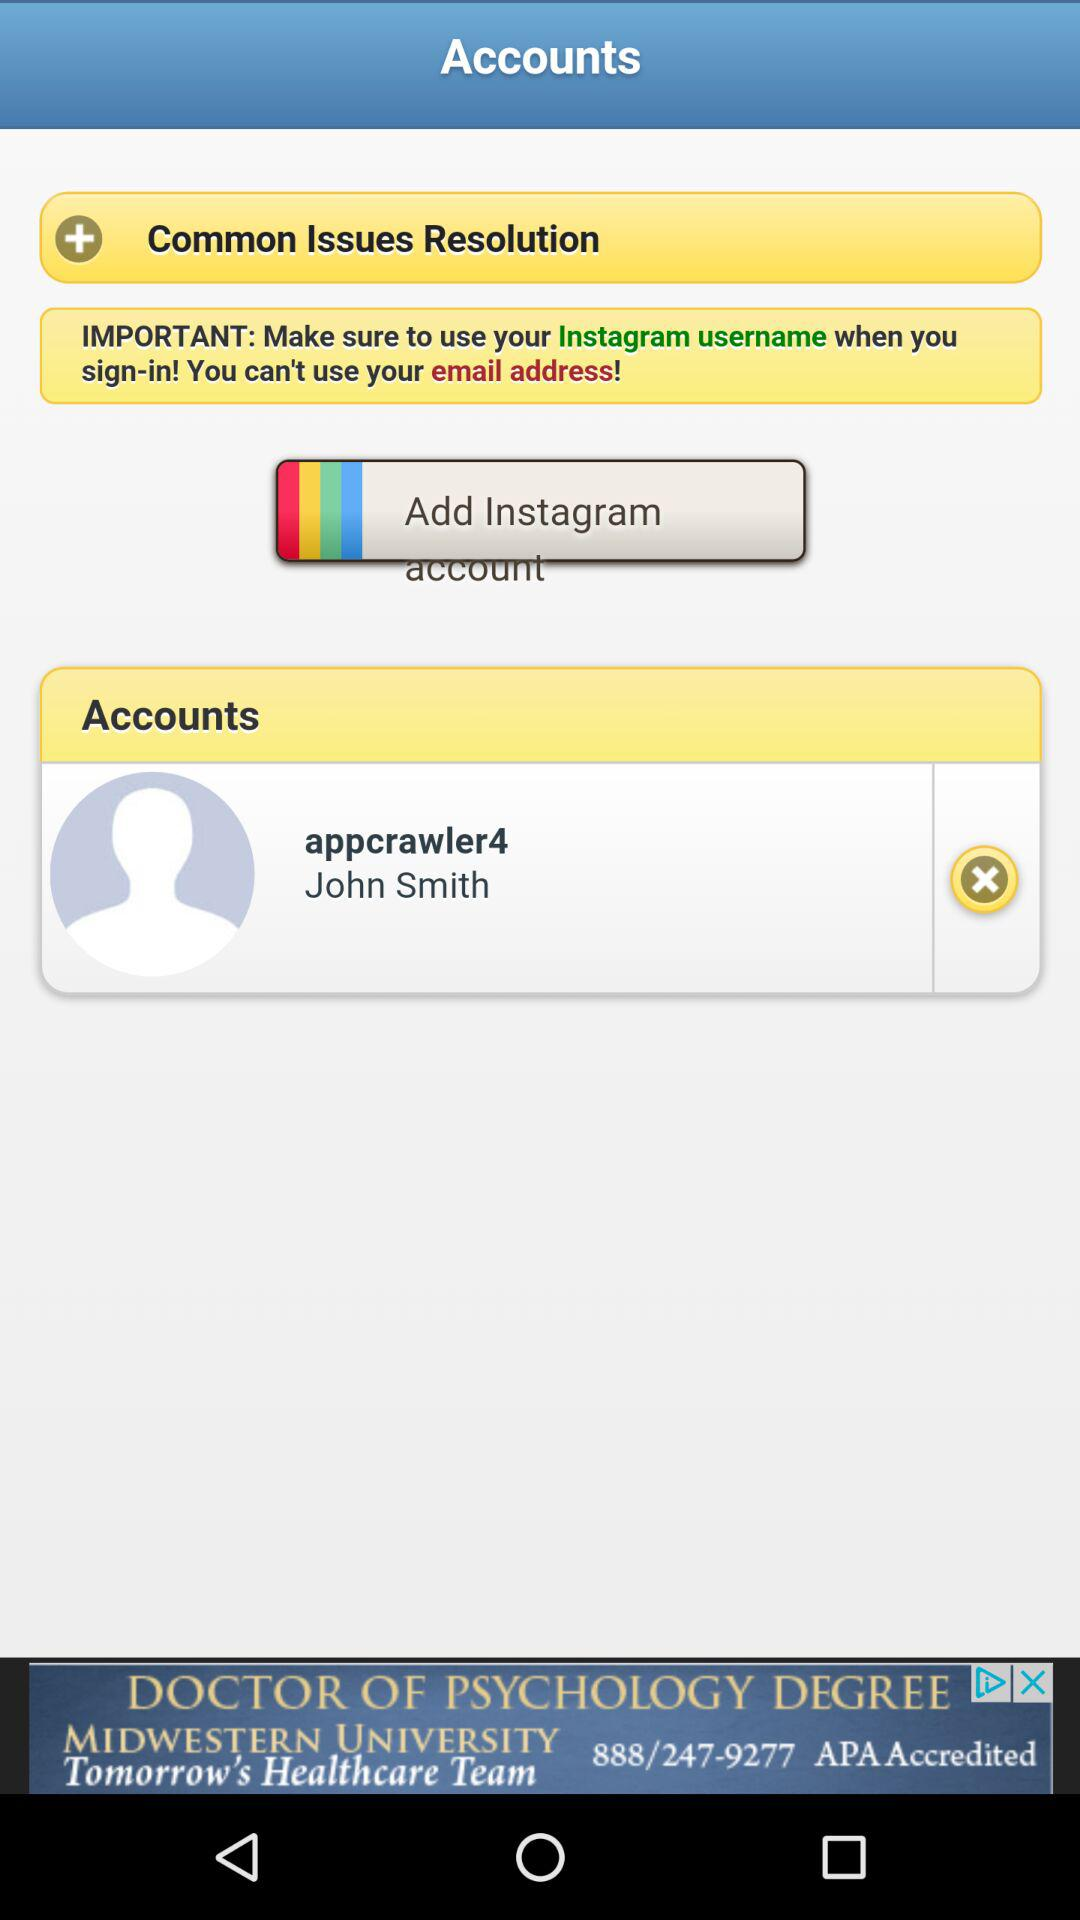What is the user name? The user name is John Smith. 